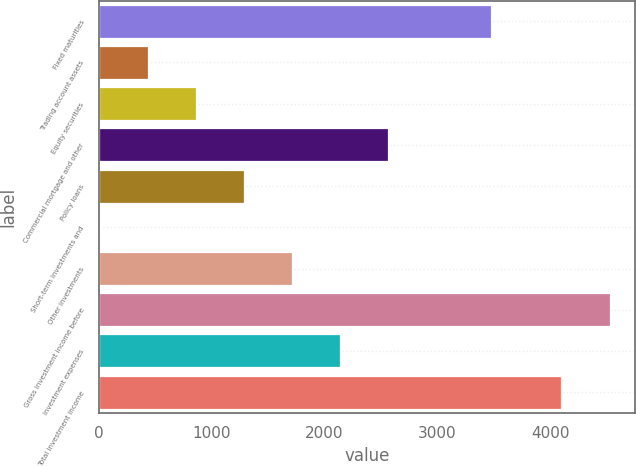<chart> <loc_0><loc_0><loc_500><loc_500><bar_chart><fcel>Fixed maturities<fcel>Trading account assets<fcel>Equity securities<fcel>Commercial mortgage and other<fcel>Policy loans<fcel>Short-term investments and<fcel>Other investments<fcel>Gross investment income before<fcel>Investment expenses<fcel>Total investment income<nl><fcel>3472<fcel>434.3<fcel>859.6<fcel>2560.8<fcel>1284.9<fcel>9<fcel>1710.2<fcel>4522.3<fcel>2135.5<fcel>4097<nl></chart> 